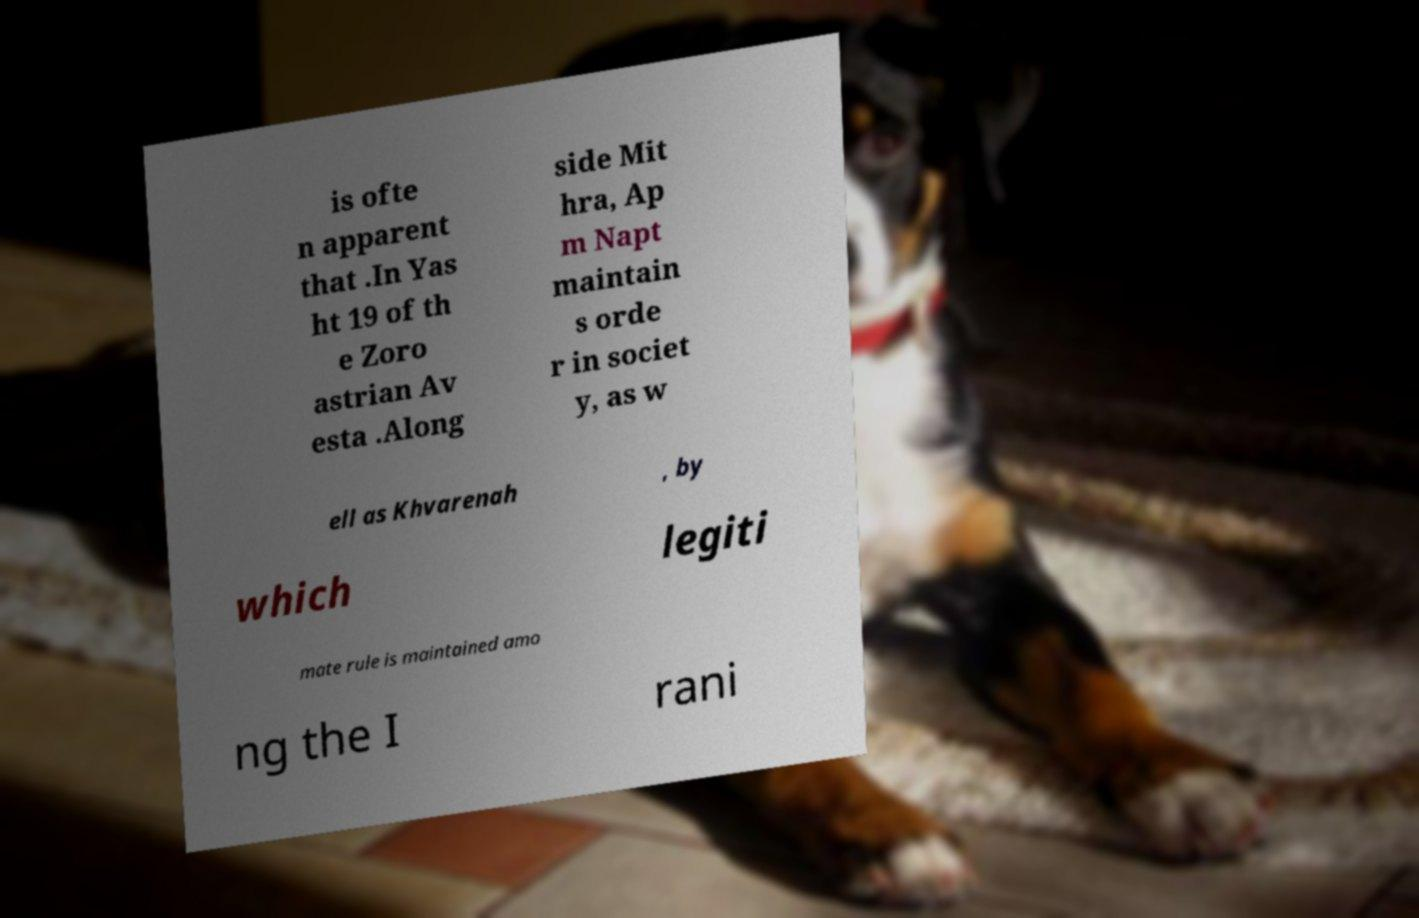What messages or text are displayed in this image? I need them in a readable, typed format. is ofte n apparent that .In Yas ht 19 of th e Zoro astrian Av esta .Along side Mit hra, Ap m Napt maintain s orde r in societ y, as w ell as Khvarenah , by which legiti mate rule is maintained amo ng the I rani 